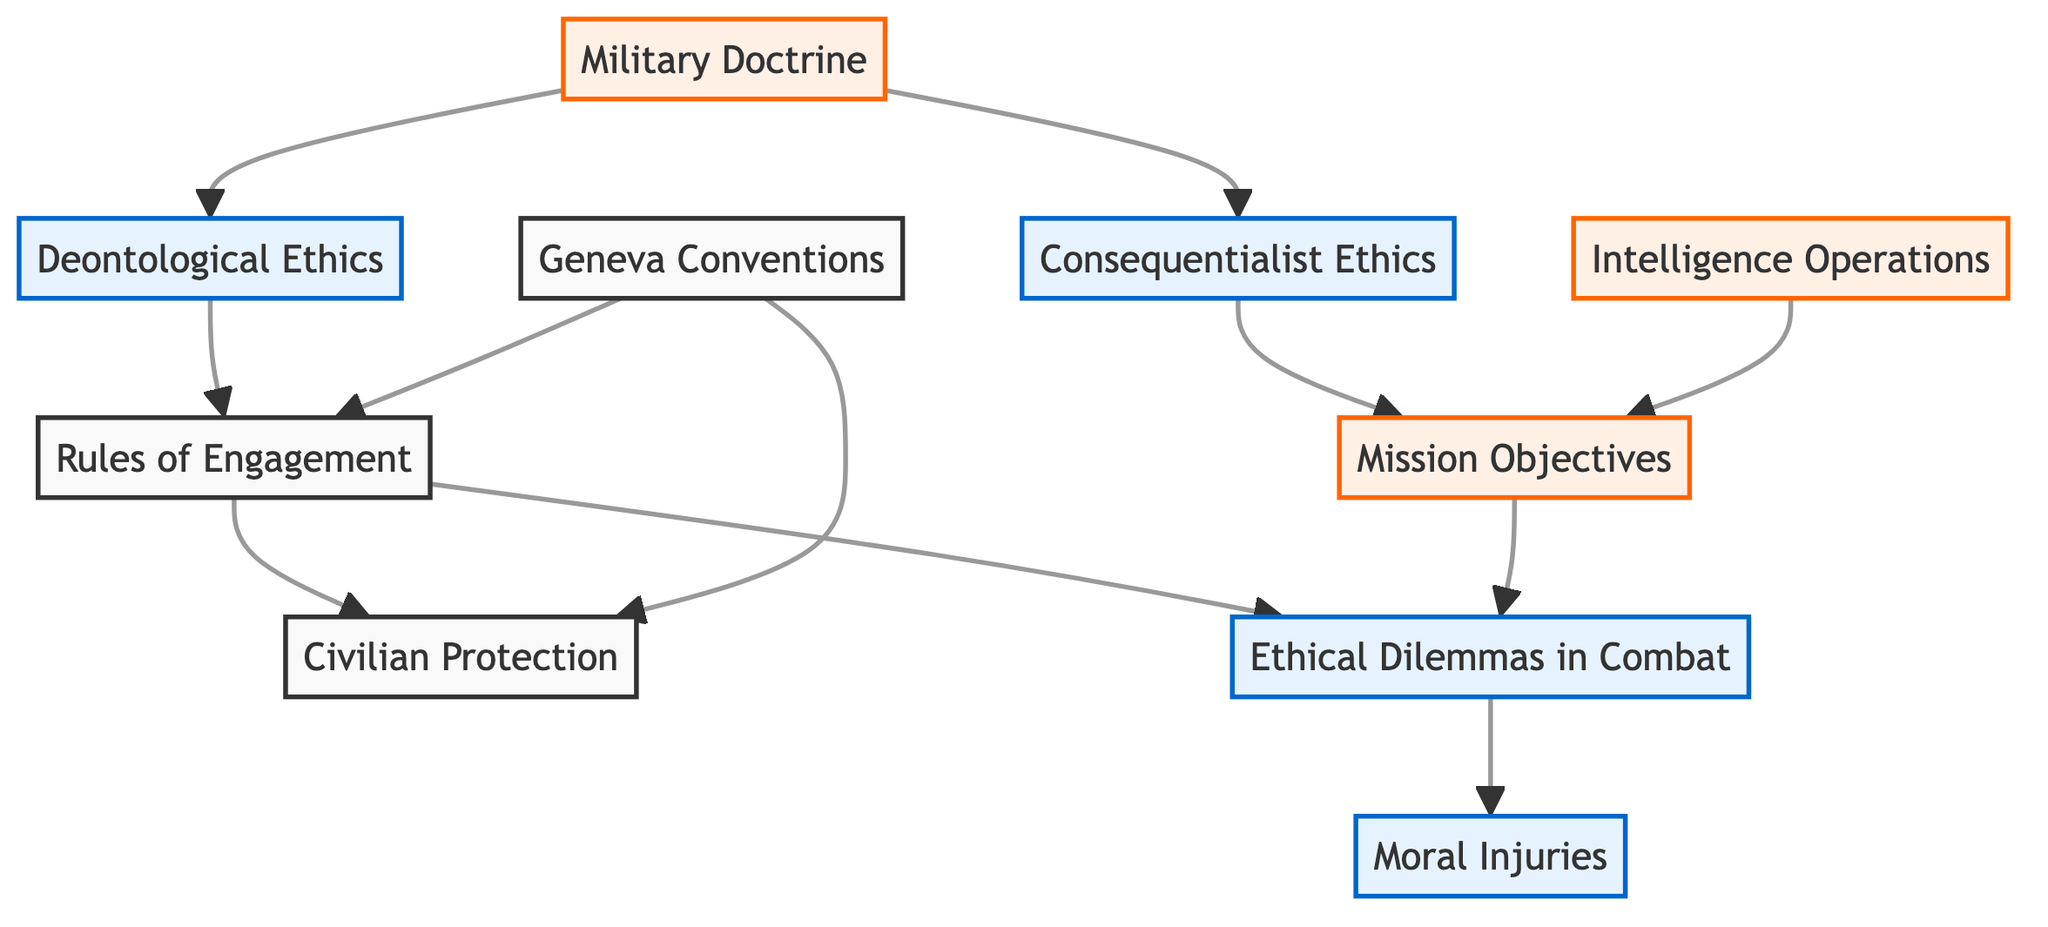What is the main focus of Deontological Ethics in this diagram? Deontological Ethics focuses on following established rules, duties, and moral principles, as defined in the description of that node.
Answer: following established rules How many elements are connected to Rules of Engagement? There are two elements connected to Rules of Engagement: Civilian Protection and Ethical Dilemmas in Combat.
Answer: 2 Which two ethical frameworks are represented in the diagram? The two ethical frameworks represented are Deontological Ethics and Consequentialist Ethics, as indicated by the respective nodes.
Answer: Deontological Ethics, Consequentialist Ethics What does the Geneva Conventions influence in the diagram? The Geneva Conventions influence both Rules of Engagement and Civilian Protection, as shown by the connections emanating from that node.
Answer: Rules of Engagement, Civilian Protection Which element is affected by Ethical Dilemmas in Combat? The element affected by Ethical Dilemmas in Combat is Moral Injuries, as indicated by the directed link from the former to the latter.
Answer: Moral Injuries How does Military Doctrine relate to ethical frameworks? Military Doctrine relates to both Deontological Ethics and Consequentialist Ethics, showing its foundational role in guiding military decision-making specified in the diagram.
Answer: Deontological Ethics, Consequentialist Ethics What are the two purposes of Intelligence Operations indicated in the diagram? Intelligence Operations are linked to Mission Objectives, suggesting its role in guiding decisions towards achieving those objectives.
Answer: Mission Objectives What outcomes are connected to the Rules of Engagement? The outcomes connected to the Rules of Engagement are Civilian Protection and Ethical Dilemmas in Combat, highlighting the implications of engagement rules in these areas.
Answer: Civilian Protection, Ethical Dilemmas in Combat 